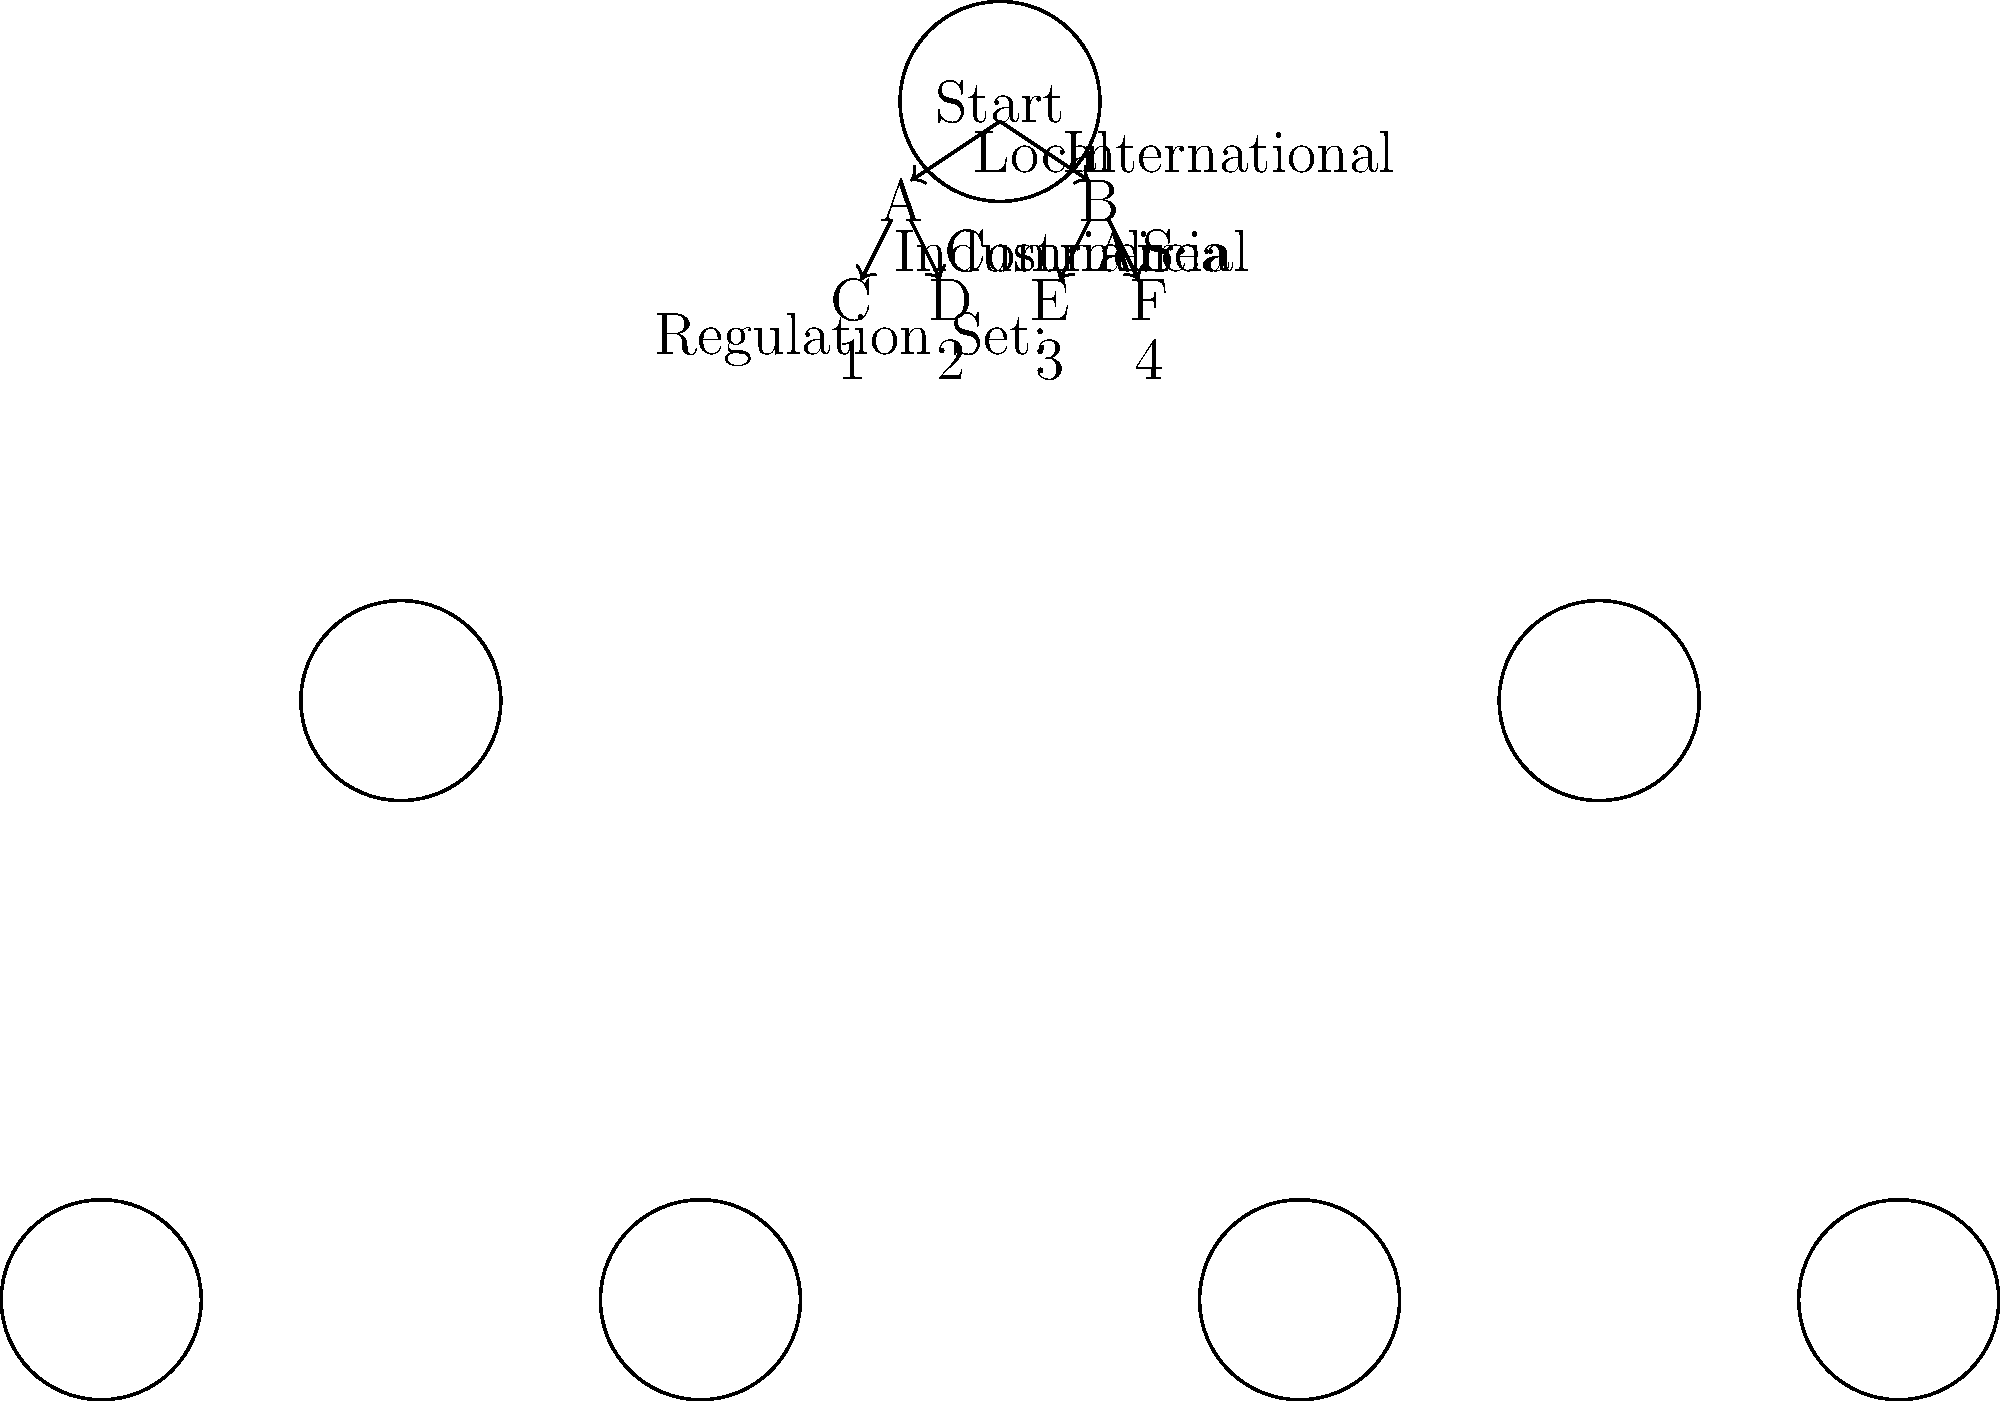Based on the decision tree diagram, which set of regulations would apply to an international sea transportation scenario? To determine the applicable set of regulations for an international sea transportation scenario, we need to follow the decision tree step-by-step:

1. We start at the top node labeled "Start".
2. From "Start", we have two options: "Local" and "International". Since the scenario involves international transportation, we follow the "International" path to node B.
3. At node B, we have two further options: "Air" and "Sea". As the scenario specifically mentions sea transportation, we follow the "Sea" path.
4. This leads us to the rightmost bottom node, labeled F.
5. Below node F, we can see that it corresponds to Regulation Set 4.

Therefore, based on the decision tree, the set of regulations that would apply to an international sea transportation scenario is Regulation Set 4.
Answer: Regulation Set 4 